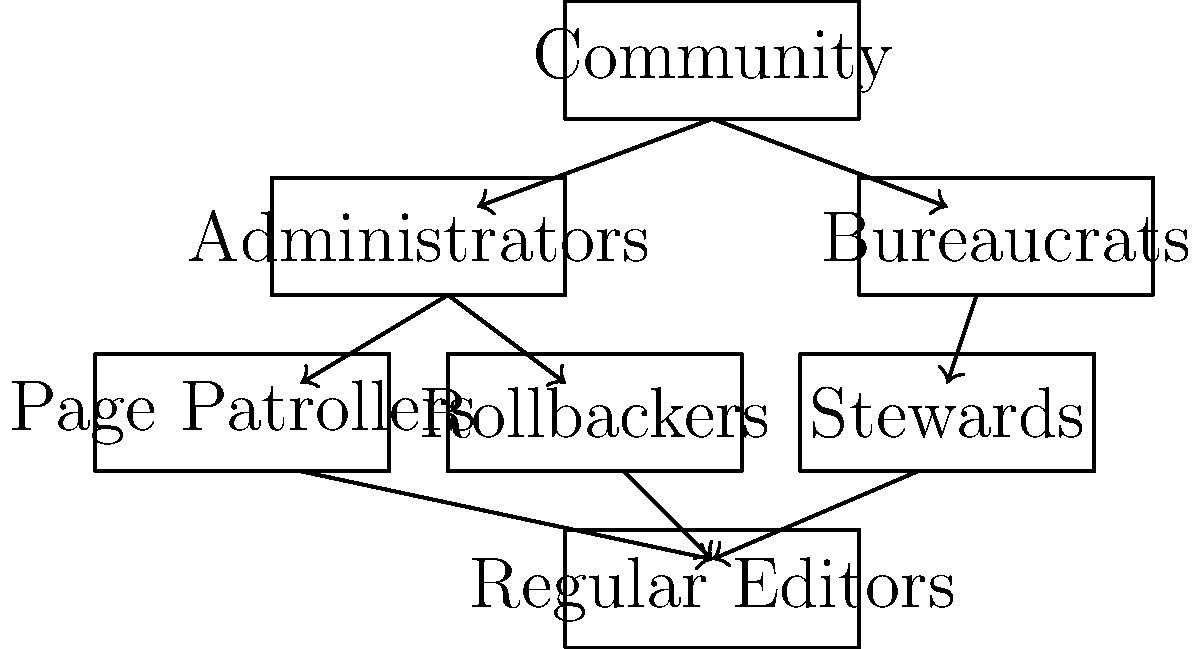Based on the organizational chart of Wikipedia's editing hierarchy, which role appears to have the most direct oversight over Regular Editors? To answer this question, let's analyze the organizational chart step-by-step:

1. At the top of the hierarchy, we see the "Community" level.
2. Directly below the Community, we have two main branches: "Administrators" and "Bureaucrats".
3. Under the Administrators, we see three sub-roles: "Page Patrollers", "Rollbackers", and "Stewards".
4. At the bottom of the chart, we find the "Regular Editors".
5. Looking at the arrows connecting the different roles, we can see that all three sub-roles under Administrators (Page Patrollers, Rollbackers, and Stewards) have direct arrows pointing to the Regular Editors.
6. This indicates that these three roles have some form of direct oversight or interaction with Regular Editors.
7. Among these three roles, none appears to have more prominence or a stronger connection to Regular Editors than the others.
8. However, since all these roles fall under the "Administrators" branch, we can conclude that Administrators have the most comprehensive oversight over Regular Editors.

Therefore, based on this organizational structure, Administrators appear to have the most direct oversight over Regular Editors through their sub-roles of Page Patrollers, Rollbackers, and Stewards.
Answer: Administrators 